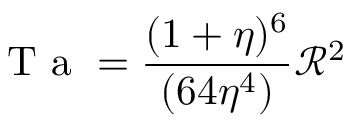Convert formula to latex. <formula><loc_0><loc_0><loc_500><loc_500>T a = \frac { ( 1 + \eta ) ^ { 6 } } { ( 6 4 \eta ^ { 4 } ) } \mathcal { R } ^ { 2 }</formula> 